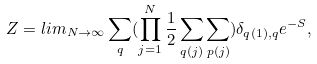Convert formula to latex. <formula><loc_0><loc_0><loc_500><loc_500>Z = l i m _ { N \rightarrow \infty } \sum _ { q } ( \prod _ { j = 1 } ^ { N } \frac { 1 } { 2 } \sum _ { q ( j ) } \sum _ { p ( j ) } ) \delta _ { q ( 1 ) , q } e ^ { - S } ,</formula> 